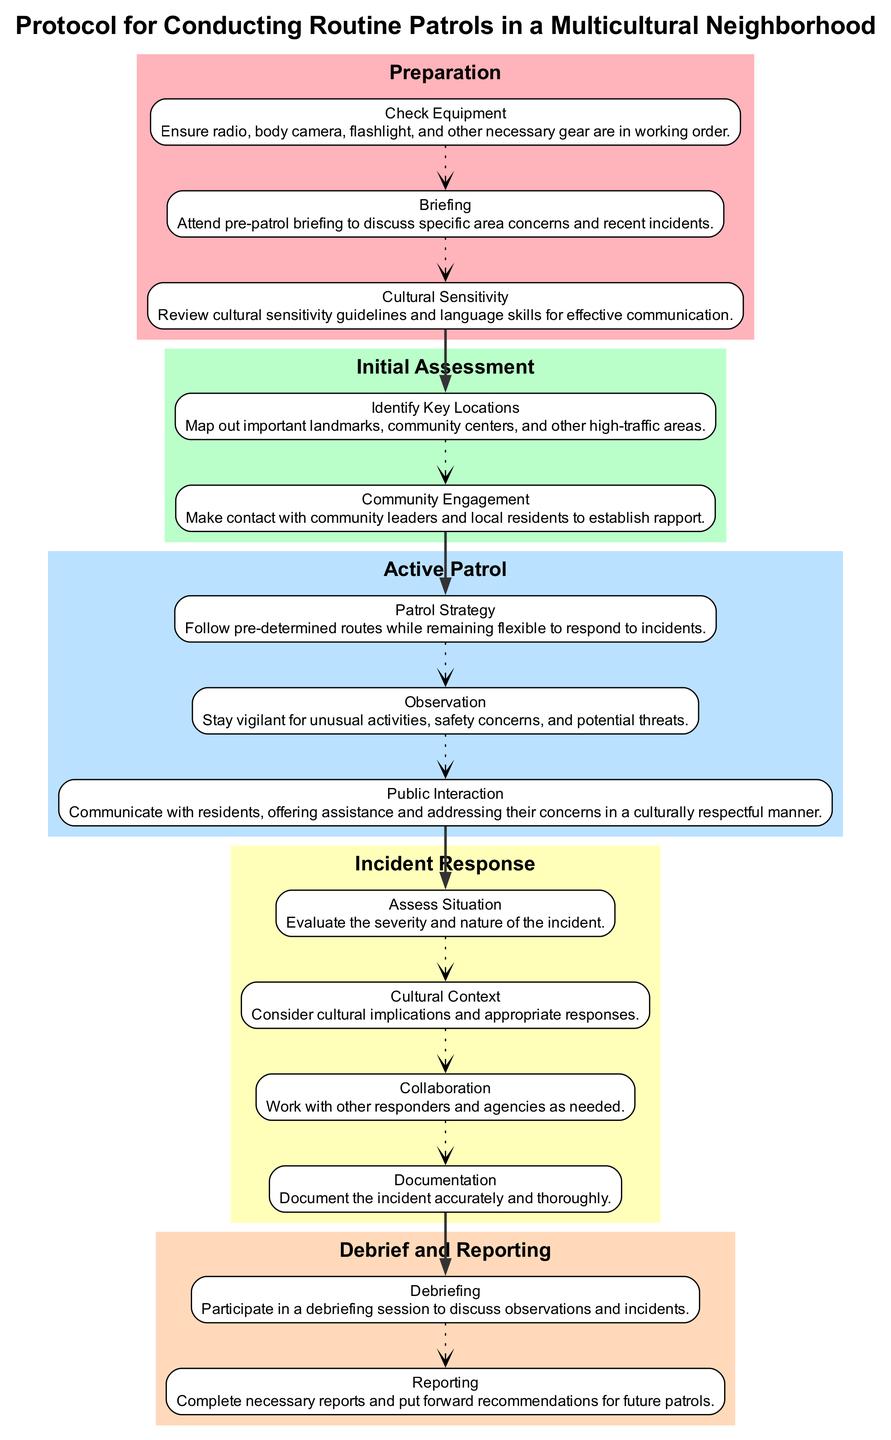What is the first main element in the diagram? The first main element is labeled as "Preparation," which outlines the initial steps to be taken before beginning the patrol. It's the starting point of the flow chart.
Answer: Preparation How many subtasks are there under the "Active Patrol" element? The "Active Patrol" element has three subtasks: Patrol Strategy, Observation, and Public Interaction. Therefore, the total count is three.
Answer: 3 What connects the last subtask of "Initial Assessment" to the first subtask of "Active Patrol"? The last subtask under "Initial Assessment" is "Community Engagement," and it connects to the first subtask of "Active Patrol," which is "Patrol Strategy," via a bold edge signifying a transition in the procedure.
Answer: Patrol Strategy What are the two main considerations under "Incident Response"? The two main considerations are "Cultural Context" and "Collaboration," which emphasize understanding cultural implications and working with other agencies, respectively.
Answer: Cultural Context, Collaboration What represents the relationship between the elements in the flow chart? The elements are connected by edges; specifically, the arrows indicate the sequence of steps to be followed in the patrol protocol. Each edge signifies a transition from one main element to another.
Answer: Edges What type of response is required when assessing an incident? When assessing an incident, the required response involves evaluating the severity and nature of the incident, determining how to proceed based on that assessment.
Answer: Assess Situation How many total main elements are involved in the protocol? There are five main elements in the protocol, which are Preparation, Initial Assessment, Active Patrol, Incident Response, and Debrief and Reporting, each representing a step in the routine patrol process.
Answer: 5 What is the purpose of the "Debrief and Reporting" element? The purpose of the "Debrief and Reporting" element is to conduct a post-patrol analysis and documentation of the events that occurred during the patrol, ensuring all observations are recorded.
Answer: Post-patrol analysis What guidelines should be reviewed for effective communication? Cultural sensitivity guidelines should be reviewed for effective communication, ensuring that interactions with the community are respectful and appropriate given the diversity of the neighborhood.
Answer: Cultural sensitivity guidelines 